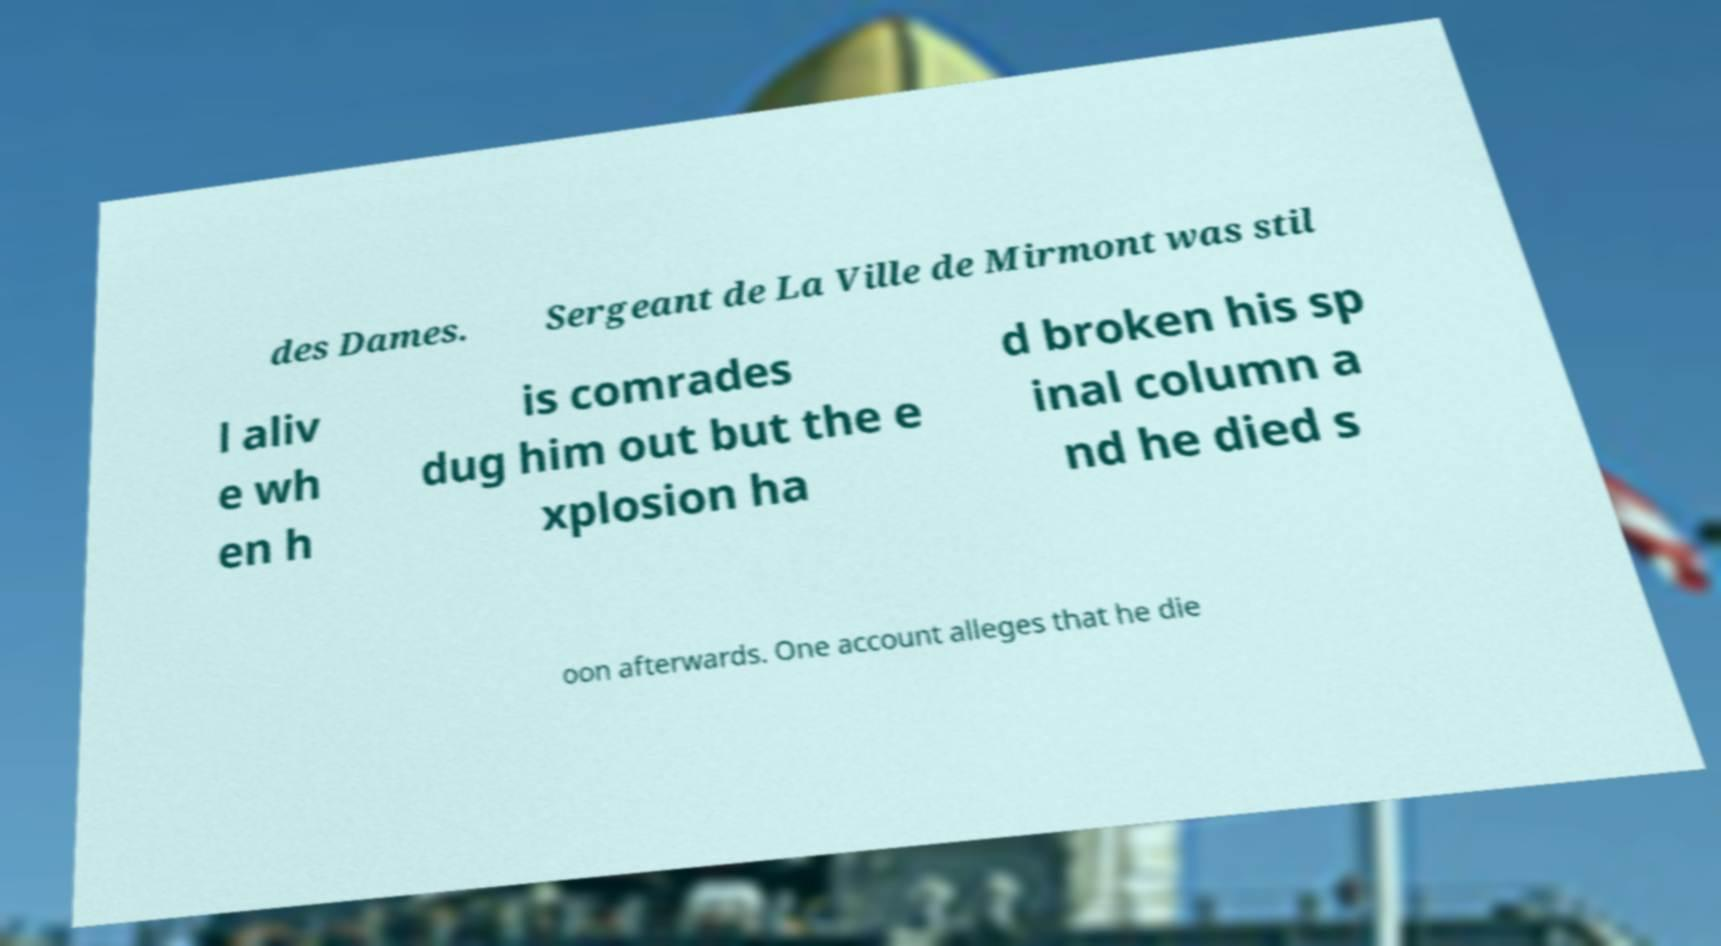Could you assist in decoding the text presented in this image and type it out clearly? des Dames. Sergeant de La Ville de Mirmont was stil l aliv e wh en h is comrades dug him out but the e xplosion ha d broken his sp inal column a nd he died s oon afterwards. One account alleges that he die 